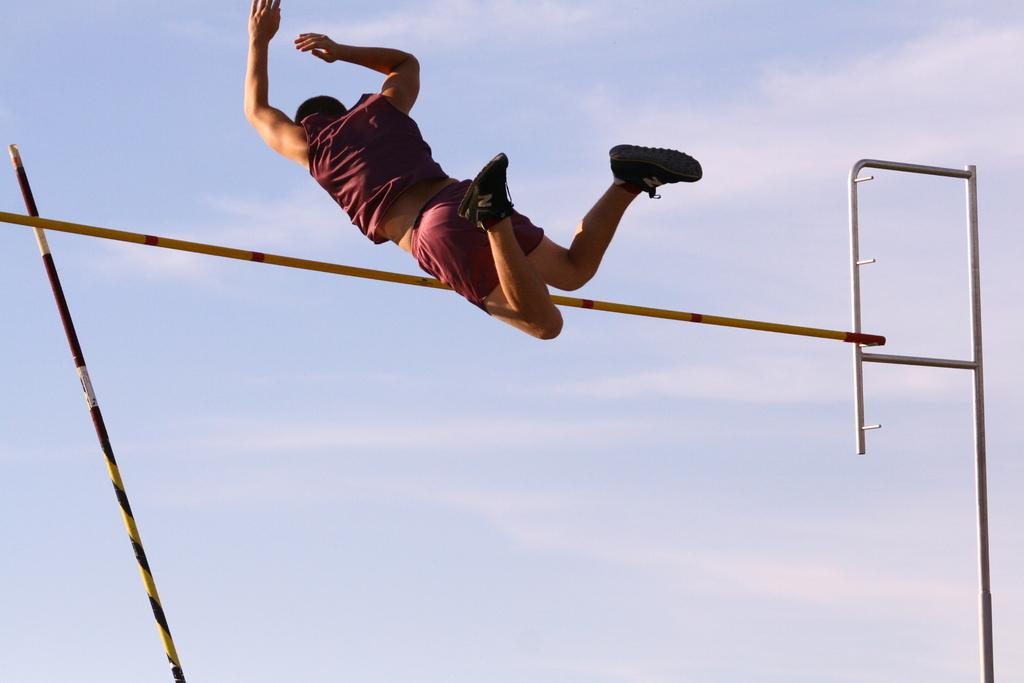What objects are located in the middle of the image? There are sticks in the middle of the image. What is the person in the image doing? The person is jumping in the image. What can be seen in the background of the image? There are clouds and the sky visible in the background of the image. Can you tell me how many snails are crawling on the person's back in the image? There are no snails present in the image; the person is jumping with no visible snails. 